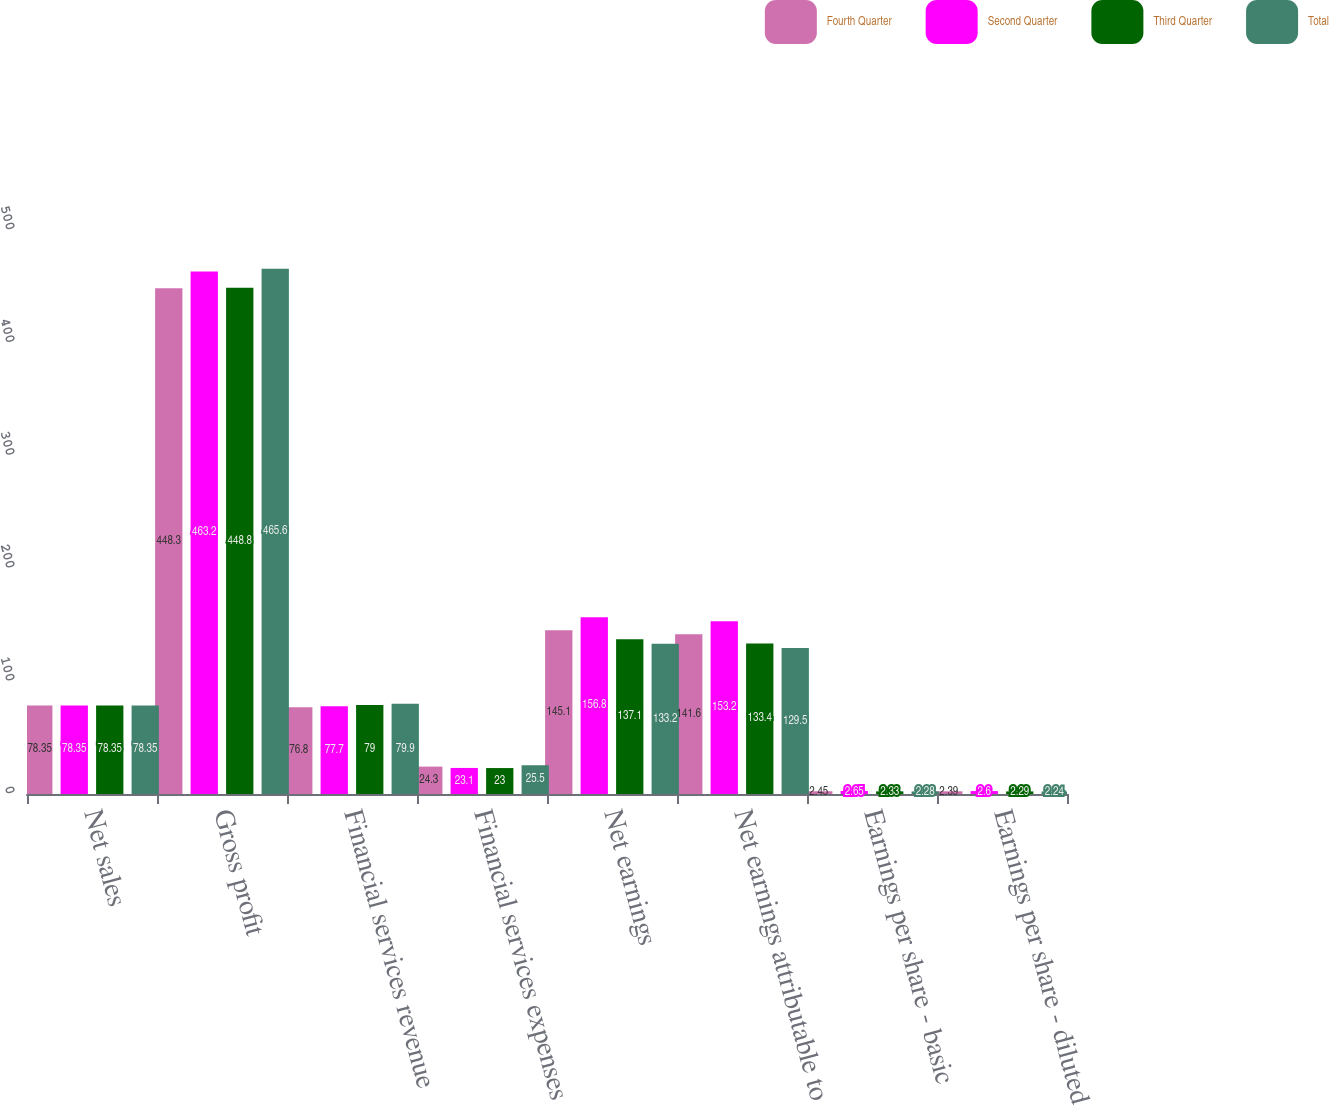<chart> <loc_0><loc_0><loc_500><loc_500><stacked_bar_chart><ecel><fcel>Net sales<fcel>Gross profit<fcel>Financial services revenue<fcel>Financial services expenses<fcel>Net earnings<fcel>Net earnings attributable to<fcel>Earnings per share - basic<fcel>Earnings per share - diluted<nl><fcel>Fourth Quarter<fcel>78.35<fcel>448.3<fcel>76.8<fcel>24.3<fcel>145.1<fcel>141.6<fcel>2.45<fcel>2.39<nl><fcel>Second Quarter<fcel>78.35<fcel>463.2<fcel>77.7<fcel>23.1<fcel>156.8<fcel>153.2<fcel>2.65<fcel>2.6<nl><fcel>Third Quarter<fcel>78.35<fcel>448.8<fcel>79<fcel>23<fcel>137.1<fcel>133.4<fcel>2.33<fcel>2.29<nl><fcel>Total<fcel>78.35<fcel>465.6<fcel>79.9<fcel>25.5<fcel>133.2<fcel>129.5<fcel>2.28<fcel>2.24<nl></chart> 